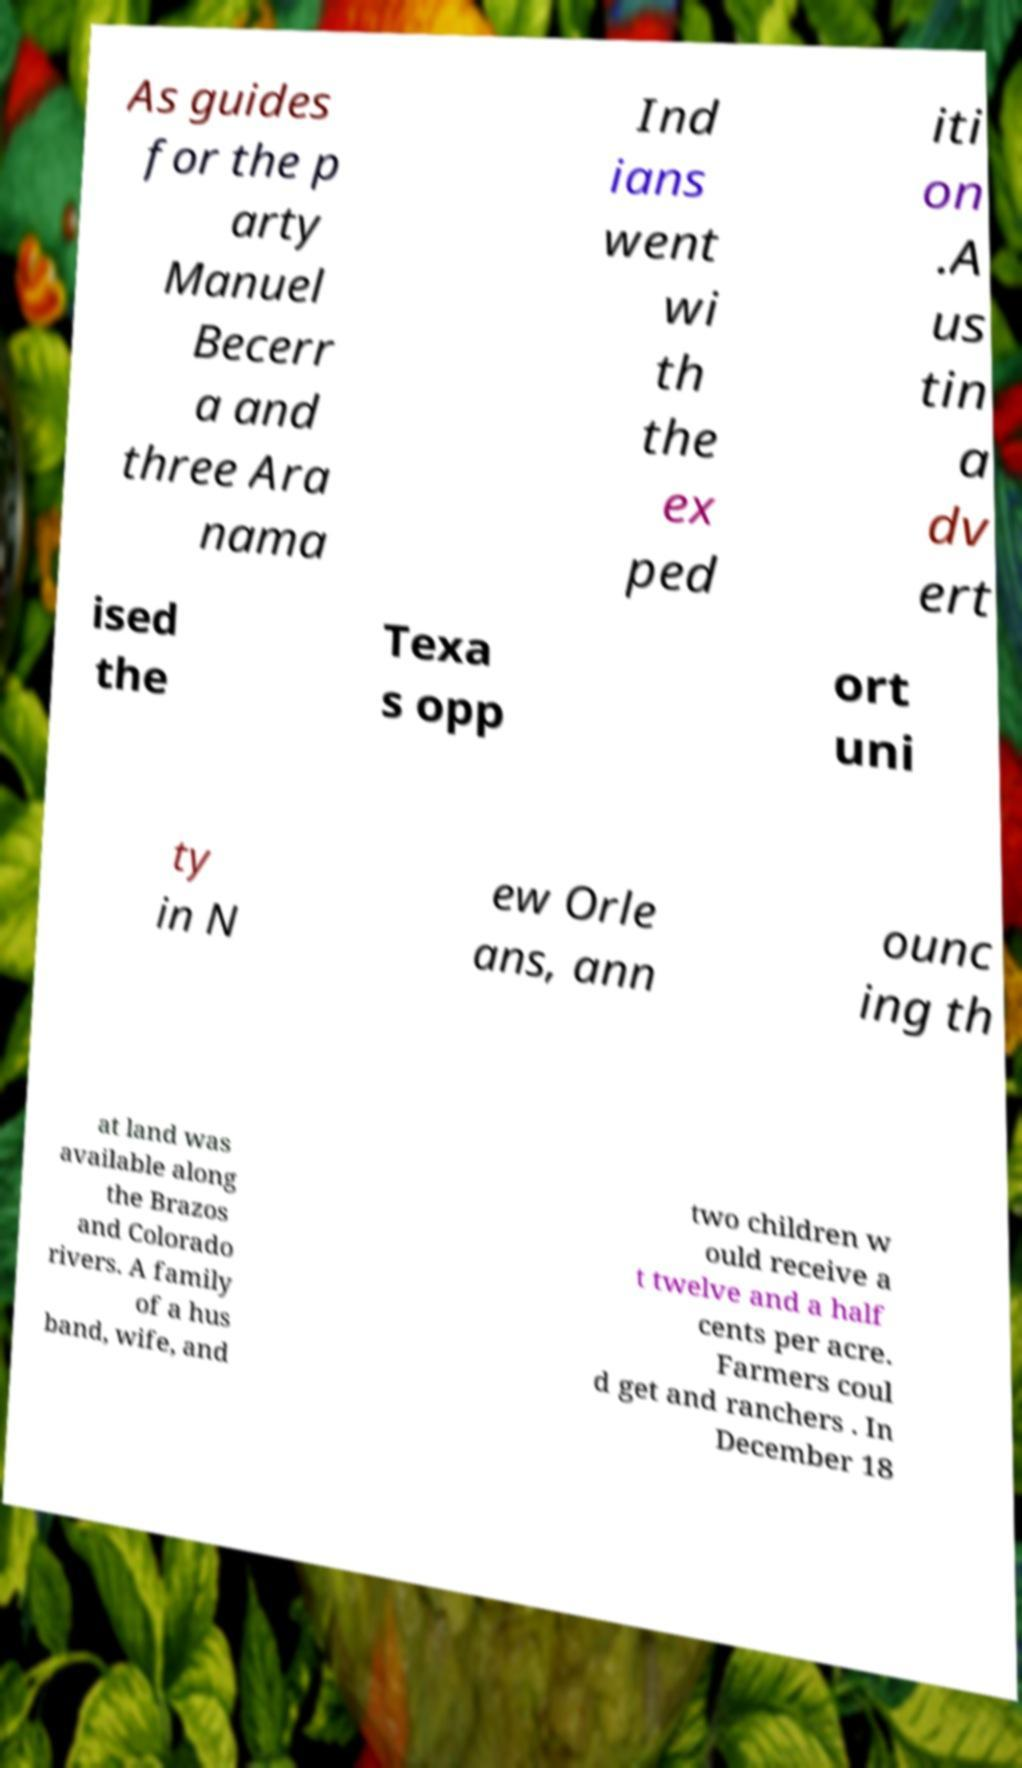Could you extract and type out the text from this image? As guides for the p arty Manuel Becerr a and three Ara nama Ind ians went wi th the ex ped iti on .A us tin a dv ert ised the Texa s opp ort uni ty in N ew Orle ans, ann ounc ing th at land was available along the Brazos and Colorado rivers. A family of a hus band, wife, and two children w ould receive a t twelve and a half cents per acre. Farmers coul d get and ranchers . In December 18 